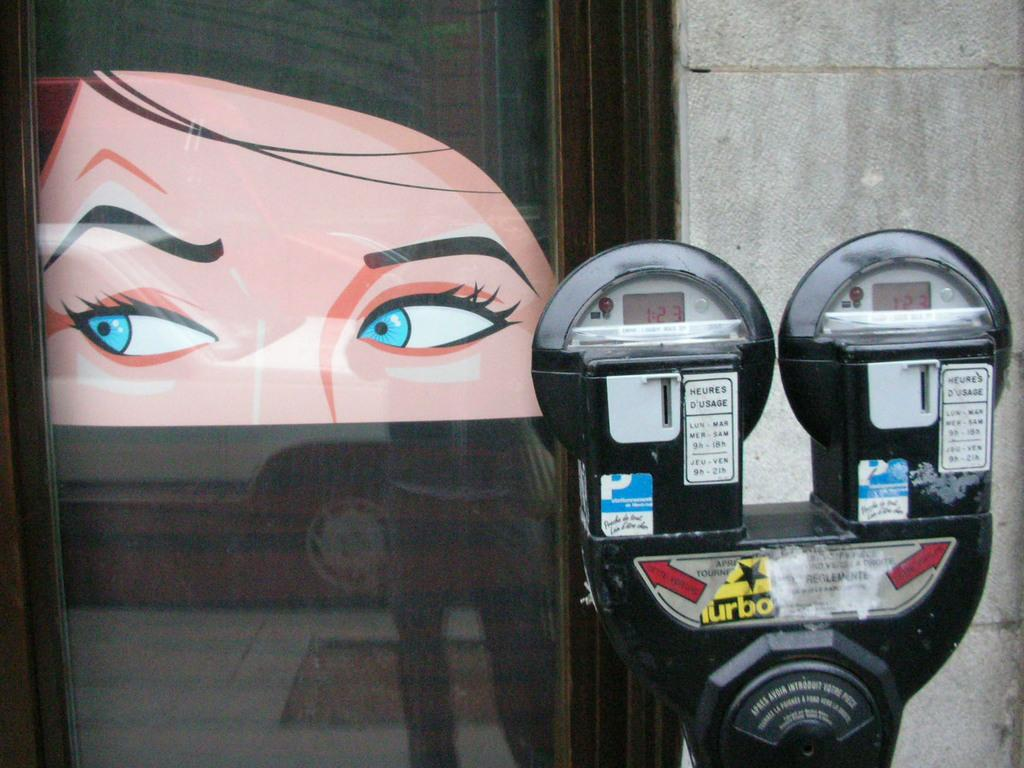<image>
Present a compact description of the photo's key features. A parking meter with a turbo sticker on it in front of a building. 